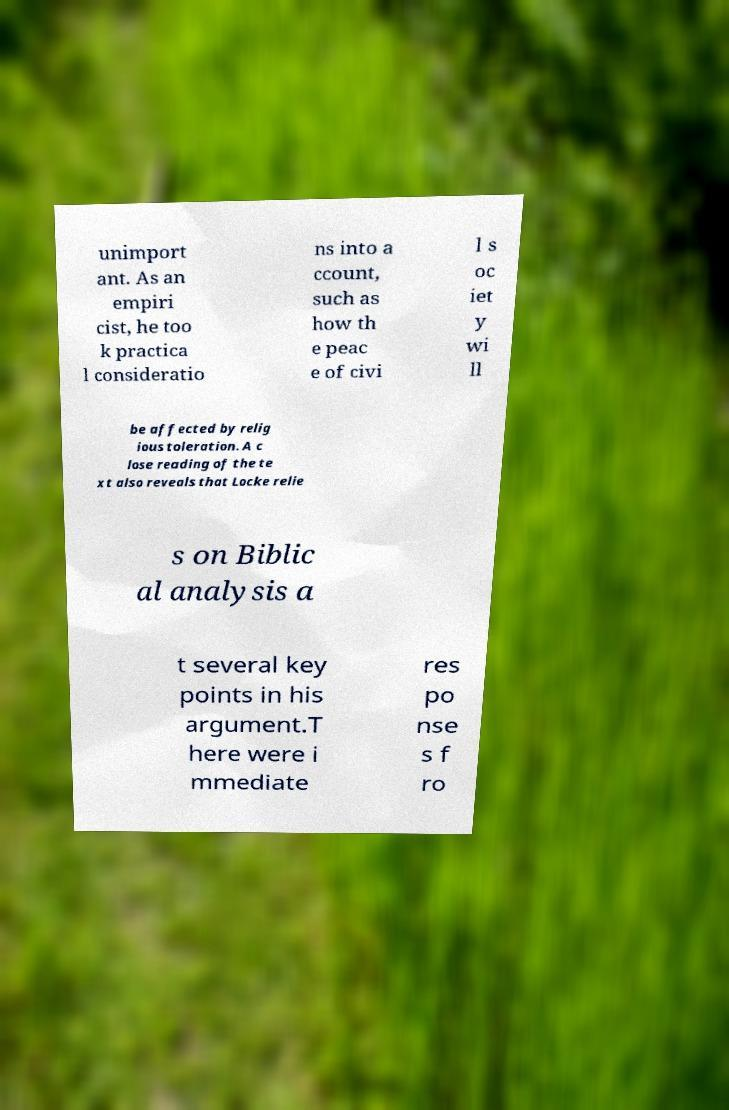Please read and relay the text visible in this image. What does it say? unimport ant. As an empiri cist, he too k practica l consideratio ns into a ccount, such as how th e peac e of civi l s oc iet y wi ll be affected by relig ious toleration. A c lose reading of the te xt also reveals that Locke relie s on Biblic al analysis a t several key points in his argument.T here were i mmediate res po nse s f ro 